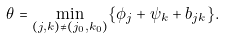Convert formula to latex. <formula><loc_0><loc_0><loc_500><loc_500>\theta = \min _ { ( j , k ) \neq ( j _ { 0 } , k _ { 0 } ) } \{ \phi _ { j } + \psi _ { k } + b _ { j k } \} .</formula> 